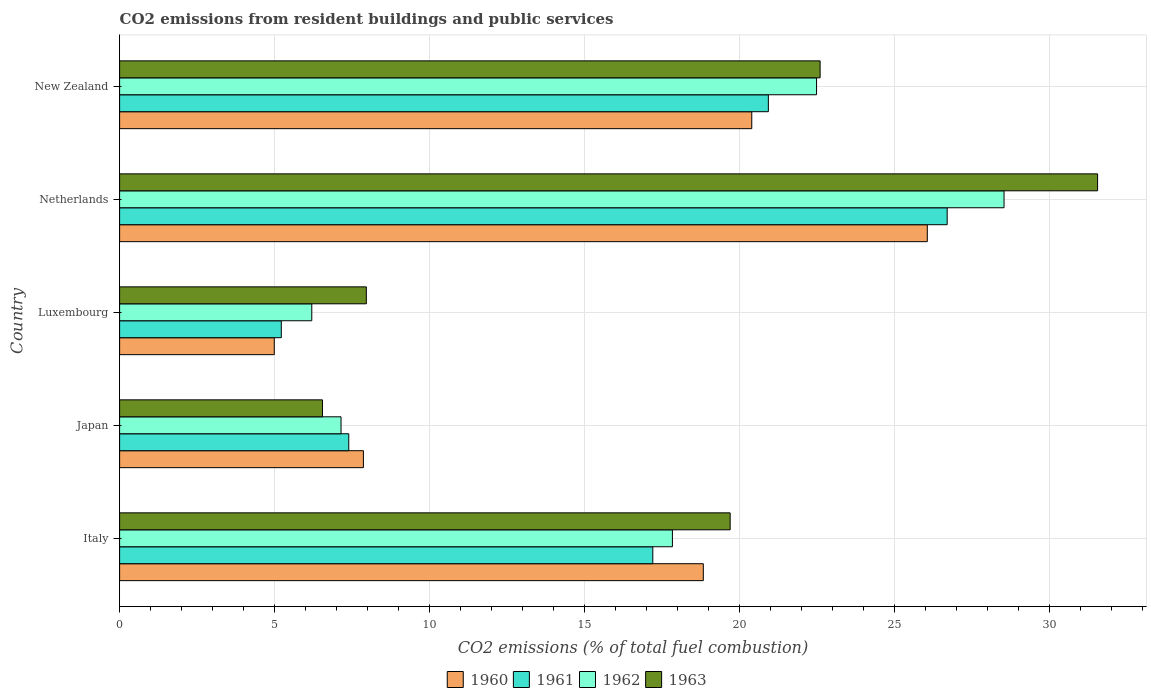How many bars are there on the 5th tick from the top?
Give a very brief answer. 4. What is the total CO2 emitted in 1961 in Italy?
Keep it short and to the point. 17.2. Across all countries, what is the maximum total CO2 emitted in 1962?
Offer a terse response. 28.52. Across all countries, what is the minimum total CO2 emitted in 1960?
Offer a very short reply. 4.99. In which country was the total CO2 emitted in 1961 maximum?
Your response must be concise. Netherlands. In which country was the total CO2 emitted in 1963 minimum?
Offer a very short reply. Japan. What is the total total CO2 emitted in 1960 in the graph?
Your response must be concise. 78.12. What is the difference between the total CO2 emitted in 1963 in Netherlands and that in New Zealand?
Provide a succinct answer. 8.95. What is the difference between the total CO2 emitted in 1963 in Japan and the total CO2 emitted in 1960 in New Zealand?
Keep it short and to the point. -13.85. What is the average total CO2 emitted in 1960 per country?
Offer a very short reply. 15.62. What is the difference between the total CO2 emitted in 1962 and total CO2 emitted in 1960 in Luxembourg?
Give a very brief answer. 1.21. What is the ratio of the total CO2 emitted in 1962 in Italy to that in Netherlands?
Provide a short and direct response. 0.63. Is the difference between the total CO2 emitted in 1962 in Italy and Luxembourg greater than the difference between the total CO2 emitted in 1960 in Italy and Luxembourg?
Give a very brief answer. No. What is the difference between the highest and the second highest total CO2 emitted in 1961?
Provide a short and direct response. 5.77. What is the difference between the highest and the lowest total CO2 emitted in 1961?
Your answer should be compact. 21.48. Is the sum of the total CO2 emitted in 1960 in Luxembourg and Netherlands greater than the maximum total CO2 emitted in 1961 across all countries?
Make the answer very short. Yes. What does the 4th bar from the bottom in Japan represents?
Your answer should be compact. 1963. How many bars are there?
Offer a terse response. 20. How many countries are there in the graph?
Provide a succinct answer. 5. What is the difference between two consecutive major ticks on the X-axis?
Make the answer very short. 5. Are the values on the major ticks of X-axis written in scientific E-notation?
Give a very brief answer. No. Does the graph contain any zero values?
Your answer should be very brief. No. Where does the legend appear in the graph?
Provide a succinct answer. Bottom center. What is the title of the graph?
Make the answer very short. CO2 emissions from resident buildings and public services. Does "1999" appear as one of the legend labels in the graph?
Make the answer very short. No. What is the label or title of the X-axis?
Offer a terse response. CO2 emissions (% of total fuel combustion). What is the label or title of the Y-axis?
Keep it short and to the point. Country. What is the CO2 emissions (% of total fuel combustion) of 1960 in Italy?
Offer a very short reply. 18.83. What is the CO2 emissions (% of total fuel combustion) in 1961 in Italy?
Provide a succinct answer. 17.2. What is the CO2 emissions (% of total fuel combustion) of 1962 in Italy?
Ensure brevity in your answer.  17.83. What is the CO2 emissions (% of total fuel combustion) of 1963 in Italy?
Ensure brevity in your answer.  19.69. What is the CO2 emissions (% of total fuel combustion) of 1960 in Japan?
Your answer should be very brief. 7.86. What is the CO2 emissions (% of total fuel combustion) in 1961 in Japan?
Ensure brevity in your answer.  7.39. What is the CO2 emissions (% of total fuel combustion) of 1962 in Japan?
Offer a terse response. 7.14. What is the CO2 emissions (% of total fuel combustion) in 1963 in Japan?
Make the answer very short. 6.54. What is the CO2 emissions (% of total fuel combustion) in 1960 in Luxembourg?
Provide a succinct answer. 4.99. What is the CO2 emissions (% of total fuel combustion) in 1961 in Luxembourg?
Offer a terse response. 5.21. What is the CO2 emissions (% of total fuel combustion) in 1962 in Luxembourg?
Give a very brief answer. 6.2. What is the CO2 emissions (% of total fuel combustion) in 1963 in Luxembourg?
Your answer should be very brief. 7.96. What is the CO2 emissions (% of total fuel combustion) of 1960 in Netherlands?
Offer a very short reply. 26.05. What is the CO2 emissions (% of total fuel combustion) of 1961 in Netherlands?
Ensure brevity in your answer.  26.69. What is the CO2 emissions (% of total fuel combustion) of 1962 in Netherlands?
Your response must be concise. 28.52. What is the CO2 emissions (% of total fuel combustion) of 1963 in Netherlands?
Offer a terse response. 31.54. What is the CO2 emissions (% of total fuel combustion) of 1960 in New Zealand?
Offer a very short reply. 20.39. What is the CO2 emissions (% of total fuel combustion) of 1961 in New Zealand?
Ensure brevity in your answer.  20.92. What is the CO2 emissions (% of total fuel combustion) of 1962 in New Zealand?
Offer a terse response. 22.48. What is the CO2 emissions (% of total fuel combustion) in 1963 in New Zealand?
Offer a terse response. 22.59. Across all countries, what is the maximum CO2 emissions (% of total fuel combustion) of 1960?
Your answer should be compact. 26.05. Across all countries, what is the maximum CO2 emissions (% of total fuel combustion) in 1961?
Keep it short and to the point. 26.69. Across all countries, what is the maximum CO2 emissions (% of total fuel combustion) of 1962?
Keep it short and to the point. 28.52. Across all countries, what is the maximum CO2 emissions (% of total fuel combustion) of 1963?
Your answer should be compact. 31.54. Across all countries, what is the minimum CO2 emissions (% of total fuel combustion) in 1960?
Your answer should be very brief. 4.99. Across all countries, what is the minimum CO2 emissions (% of total fuel combustion) of 1961?
Your answer should be very brief. 5.21. Across all countries, what is the minimum CO2 emissions (% of total fuel combustion) in 1962?
Ensure brevity in your answer.  6.2. Across all countries, what is the minimum CO2 emissions (% of total fuel combustion) of 1963?
Provide a short and direct response. 6.54. What is the total CO2 emissions (% of total fuel combustion) in 1960 in the graph?
Give a very brief answer. 78.11. What is the total CO2 emissions (% of total fuel combustion) in 1961 in the graph?
Keep it short and to the point. 77.42. What is the total CO2 emissions (% of total fuel combustion) of 1962 in the graph?
Make the answer very short. 82.17. What is the total CO2 emissions (% of total fuel combustion) in 1963 in the graph?
Keep it short and to the point. 88.33. What is the difference between the CO2 emissions (% of total fuel combustion) of 1960 in Italy and that in Japan?
Your response must be concise. 10.96. What is the difference between the CO2 emissions (% of total fuel combustion) in 1961 in Italy and that in Japan?
Your answer should be very brief. 9.81. What is the difference between the CO2 emissions (% of total fuel combustion) of 1962 in Italy and that in Japan?
Provide a succinct answer. 10.69. What is the difference between the CO2 emissions (% of total fuel combustion) of 1963 in Italy and that in Japan?
Give a very brief answer. 13.15. What is the difference between the CO2 emissions (% of total fuel combustion) of 1960 in Italy and that in Luxembourg?
Keep it short and to the point. 13.84. What is the difference between the CO2 emissions (% of total fuel combustion) in 1961 in Italy and that in Luxembourg?
Ensure brevity in your answer.  11.98. What is the difference between the CO2 emissions (% of total fuel combustion) in 1962 in Italy and that in Luxembourg?
Your response must be concise. 11.63. What is the difference between the CO2 emissions (% of total fuel combustion) in 1963 in Italy and that in Luxembourg?
Your answer should be very brief. 11.73. What is the difference between the CO2 emissions (% of total fuel combustion) of 1960 in Italy and that in Netherlands?
Ensure brevity in your answer.  -7.22. What is the difference between the CO2 emissions (% of total fuel combustion) in 1961 in Italy and that in Netherlands?
Your response must be concise. -9.49. What is the difference between the CO2 emissions (% of total fuel combustion) of 1962 in Italy and that in Netherlands?
Ensure brevity in your answer.  -10.7. What is the difference between the CO2 emissions (% of total fuel combustion) of 1963 in Italy and that in Netherlands?
Give a very brief answer. -11.85. What is the difference between the CO2 emissions (% of total fuel combustion) in 1960 in Italy and that in New Zealand?
Provide a short and direct response. -1.56. What is the difference between the CO2 emissions (% of total fuel combustion) of 1961 in Italy and that in New Zealand?
Offer a terse response. -3.73. What is the difference between the CO2 emissions (% of total fuel combustion) of 1962 in Italy and that in New Zealand?
Provide a short and direct response. -4.65. What is the difference between the CO2 emissions (% of total fuel combustion) of 1963 in Italy and that in New Zealand?
Keep it short and to the point. -2.9. What is the difference between the CO2 emissions (% of total fuel combustion) of 1960 in Japan and that in Luxembourg?
Your answer should be very brief. 2.87. What is the difference between the CO2 emissions (% of total fuel combustion) of 1961 in Japan and that in Luxembourg?
Your response must be concise. 2.18. What is the difference between the CO2 emissions (% of total fuel combustion) in 1962 in Japan and that in Luxembourg?
Offer a very short reply. 0.94. What is the difference between the CO2 emissions (% of total fuel combustion) of 1963 in Japan and that in Luxembourg?
Your response must be concise. -1.41. What is the difference between the CO2 emissions (% of total fuel combustion) in 1960 in Japan and that in Netherlands?
Keep it short and to the point. -18.19. What is the difference between the CO2 emissions (% of total fuel combustion) in 1961 in Japan and that in Netherlands?
Your response must be concise. -19.3. What is the difference between the CO2 emissions (% of total fuel combustion) of 1962 in Japan and that in Netherlands?
Provide a short and direct response. -21.38. What is the difference between the CO2 emissions (% of total fuel combustion) of 1963 in Japan and that in Netherlands?
Your answer should be very brief. -25. What is the difference between the CO2 emissions (% of total fuel combustion) of 1960 in Japan and that in New Zealand?
Offer a very short reply. -12.53. What is the difference between the CO2 emissions (% of total fuel combustion) of 1961 in Japan and that in New Zealand?
Provide a short and direct response. -13.53. What is the difference between the CO2 emissions (% of total fuel combustion) of 1962 in Japan and that in New Zealand?
Offer a terse response. -15.34. What is the difference between the CO2 emissions (% of total fuel combustion) in 1963 in Japan and that in New Zealand?
Your response must be concise. -16.05. What is the difference between the CO2 emissions (% of total fuel combustion) in 1960 in Luxembourg and that in Netherlands?
Keep it short and to the point. -21.06. What is the difference between the CO2 emissions (% of total fuel combustion) in 1961 in Luxembourg and that in Netherlands?
Keep it short and to the point. -21.48. What is the difference between the CO2 emissions (% of total fuel combustion) in 1962 in Luxembourg and that in Netherlands?
Offer a very short reply. -22.33. What is the difference between the CO2 emissions (% of total fuel combustion) of 1963 in Luxembourg and that in Netherlands?
Make the answer very short. -23.58. What is the difference between the CO2 emissions (% of total fuel combustion) of 1960 in Luxembourg and that in New Zealand?
Make the answer very short. -15.4. What is the difference between the CO2 emissions (% of total fuel combustion) of 1961 in Luxembourg and that in New Zealand?
Provide a short and direct response. -15.71. What is the difference between the CO2 emissions (% of total fuel combustion) of 1962 in Luxembourg and that in New Zealand?
Keep it short and to the point. -16.28. What is the difference between the CO2 emissions (% of total fuel combustion) of 1963 in Luxembourg and that in New Zealand?
Offer a terse response. -14.63. What is the difference between the CO2 emissions (% of total fuel combustion) of 1960 in Netherlands and that in New Zealand?
Offer a very short reply. 5.66. What is the difference between the CO2 emissions (% of total fuel combustion) of 1961 in Netherlands and that in New Zealand?
Your answer should be very brief. 5.77. What is the difference between the CO2 emissions (% of total fuel combustion) in 1962 in Netherlands and that in New Zealand?
Give a very brief answer. 6.05. What is the difference between the CO2 emissions (% of total fuel combustion) of 1963 in Netherlands and that in New Zealand?
Ensure brevity in your answer.  8.95. What is the difference between the CO2 emissions (% of total fuel combustion) in 1960 in Italy and the CO2 emissions (% of total fuel combustion) in 1961 in Japan?
Ensure brevity in your answer.  11.43. What is the difference between the CO2 emissions (% of total fuel combustion) in 1960 in Italy and the CO2 emissions (% of total fuel combustion) in 1962 in Japan?
Your answer should be compact. 11.68. What is the difference between the CO2 emissions (% of total fuel combustion) in 1960 in Italy and the CO2 emissions (% of total fuel combustion) in 1963 in Japan?
Offer a very short reply. 12.28. What is the difference between the CO2 emissions (% of total fuel combustion) of 1961 in Italy and the CO2 emissions (% of total fuel combustion) of 1962 in Japan?
Your response must be concise. 10.05. What is the difference between the CO2 emissions (% of total fuel combustion) of 1961 in Italy and the CO2 emissions (% of total fuel combustion) of 1963 in Japan?
Offer a very short reply. 10.65. What is the difference between the CO2 emissions (% of total fuel combustion) in 1962 in Italy and the CO2 emissions (% of total fuel combustion) in 1963 in Japan?
Give a very brief answer. 11.29. What is the difference between the CO2 emissions (% of total fuel combustion) of 1960 in Italy and the CO2 emissions (% of total fuel combustion) of 1961 in Luxembourg?
Your answer should be very brief. 13.61. What is the difference between the CO2 emissions (% of total fuel combustion) in 1960 in Italy and the CO2 emissions (% of total fuel combustion) in 1962 in Luxembourg?
Give a very brief answer. 12.63. What is the difference between the CO2 emissions (% of total fuel combustion) of 1960 in Italy and the CO2 emissions (% of total fuel combustion) of 1963 in Luxembourg?
Offer a very short reply. 10.87. What is the difference between the CO2 emissions (% of total fuel combustion) of 1961 in Italy and the CO2 emissions (% of total fuel combustion) of 1962 in Luxembourg?
Provide a short and direct response. 11. What is the difference between the CO2 emissions (% of total fuel combustion) of 1961 in Italy and the CO2 emissions (% of total fuel combustion) of 1963 in Luxembourg?
Your answer should be compact. 9.24. What is the difference between the CO2 emissions (% of total fuel combustion) in 1962 in Italy and the CO2 emissions (% of total fuel combustion) in 1963 in Luxembourg?
Make the answer very short. 9.87. What is the difference between the CO2 emissions (% of total fuel combustion) in 1960 in Italy and the CO2 emissions (% of total fuel combustion) in 1961 in Netherlands?
Ensure brevity in your answer.  -7.86. What is the difference between the CO2 emissions (% of total fuel combustion) in 1960 in Italy and the CO2 emissions (% of total fuel combustion) in 1962 in Netherlands?
Offer a very short reply. -9.7. What is the difference between the CO2 emissions (% of total fuel combustion) of 1960 in Italy and the CO2 emissions (% of total fuel combustion) of 1963 in Netherlands?
Your answer should be very brief. -12.72. What is the difference between the CO2 emissions (% of total fuel combustion) in 1961 in Italy and the CO2 emissions (% of total fuel combustion) in 1962 in Netherlands?
Ensure brevity in your answer.  -11.33. What is the difference between the CO2 emissions (% of total fuel combustion) of 1961 in Italy and the CO2 emissions (% of total fuel combustion) of 1963 in Netherlands?
Your answer should be compact. -14.35. What is the difference between the CO2 emissions (% of total fuel combustion) of 1962 in Italy and the CO2 emissions (% of total fuel combustion) of 1963 in Netherlands?
Offer a terse response. -13.71. What is the difference between the CO2 emissions (% of total fuel combustion) of 1960 in Italy and the CO2 emissions (% of total fuel combustion) of 1961 in New Zealand?
Make the answer very short. -2.1. What is the difference between the CO2 emissions (% of total fuel combustion) in 1960 in Italy and the CO2 emissions (% of total fuel combustion) in 1962 in New Zealand?
Your response must be concise. -3.65. What is the difference between the CO2 emissions (% of total fuel combustion) in 1960 in Italy and the CO2 emissions (% of total fuel combustion) in 1963 in New Zealand?
Offer a very short reply. -3.77. What is the difference between the CO2 emissions (% of total fuel combustion) of 1961 in Italy and the CO2 emissions (% of total fuel combustion) of 1962 in New Zealand?
Make the answer very short. -5.28. What is the difference between the CO2 emissions (% of total fuel combustion) in 1961 in Italy and the CO2 emissions (% of total fuel combustion) in 1963 in New Zealand?
Give a very brief answer. -5.4. What is the difference between the CO2 emissions (% of total fuel combustion) in 1962 in Italy and the CO2 emissions (% of total fuel combustion) in 1963 in New Zealand?
Your answer should be compact. -4.76. What is the difference between the CO2 emissions (% of total fuel combustion) in 1960 in Japan and the CO2 emissions (% of total fuel combustion) in 1961 in Luxembourg?
Provide a short and direct response. 2.65. What is the difference between the CO2 emissions (% of total fuel combustion) in 1960 in Japan and the CO2 emissions (% of total fuel combustion) in 1962 in Luxembourg?
Give a very brief answer. 1.66. What is the difference between the CO2 emissions (% of total fuel combustion) in 1960 in Japan and the CO2 emissions (% of total fuel combustion) in 1963 in Luxembourg?
Keep it short and to the point. -0.09. What is the difference between the CO2 emissions (% of total fuel combustion) in 1961 in Japan and the CO2 emissions (% of total fuel combustion) in 1962 in Luxembourg?
Offer a terse response. 1.19. What is the difference between the CO2 emissions (% of total fuel combustion) in 1961 in Japan and the CO2 emissions (% of total fuel combustion) in 1963 in Luxembourg?
Provide a short and direct response. -0.57. What is the difference between the CO2 emissions (% of total fuel combustion) of 1962 in Japan and the CO2 emissions (% of total fuel combustion) of 1963 in Luxembourg?
Your answer should be very brief. -0.82. What is the difference between the CO2 emissions (% of total fuel combustion) of 1960 in Japan and the CO2 emissions (% of total fuel combustion) of 1961 in Netherlands?
Your answer should be compact. -18.83. What is the difference between the CO2 emissions (% of total fuel combustion) of 1960 in Japan and the CO2 emissions (% of total fuel combustion) of 1962 in Netherlands?
Offer a very short reply. -20.66. What is the difference between the CO2 emissions (% of total fuel combustion) in 1960 in Japan and the CO2 emissions (% of total fuel combustion) in 1963 in Netherlands?
Ensure brevity in your answer.  -23.68. What is the difference between the CO2 emissions (% of total fuel combustion) of 1961 in Japan and the CO2 emissions (% of total fuel combustion) of 1962 in Netherlands?
Provide a succinct answer. -21.13. What is the difference between the CO2 emissions (% of total fuel combustion) of 1961 in Japan and the CO2 emissions (% of total fuel combustion) of 1963 in Netherlands?
Give a very brief answer. -24.15. What is the difference between the CO2 emissions (% of total fuel combustion) in 1962 in Japan and the CO2 emissions (% of total fuel combustion) in 1963 in Netherlands?
Make the answer very short. -24.4. What is the difference between the CO2 emissions (% of total fuel combustion) in 1960 in Japan and the CO2 emissions (% of total fuel combustion) in 1961 in New Zealand?
Give a very brief answer. -13.06. What is the difference between the CO2 emissions (% of total fuel combustion) of 1960 in Japan and the CO2 emissions (% of total fuel combustion) of 1962 in New Zealand?
Make the answer very short. -14.61. What is the difference between the CO2 emissions (% of total fuel combustion) in 1960 in Japan and the CO2 emissions (% of total fuel combustion) in 1963 in New Zealand?
Provide a short and direct response. -14.73. What is the difference between the CO2 emissions (% of total fuel combustion) of 1961 in Japan and the CO2 emissions (% of total fuel combustion) of 1962 in New Zealand?
Your answer should be very brief. -15.09. What is the difference between the CO2 emissions (% of total fuel combustion) of 1961 in Japan and the CO2 emissions (% of total fuel combustion) of 1963 in New Zealand?
Ensure brevity in your answer.  -15.2. What is the difference between the CO2 emissions (% of total fuel combustion) of 1962 in Japan and the CO2 emissions (% of total fuel combustion) of 1963 in New Zealand?
Your answer should be compact. -15.45. What is the difference between the CO2 emissions (% of total fuel combustion) in 1960 in Luxembourg and the CO2 emissions (% of total fuel combustion) in 1961 in Netherlands?
Provide a succinct answer. -21.7. What is the difference between the CO2 emissions (% of total fuel combustion) in 1960 in Luxembourg and the CO2 emissions (% of total fuel combustion) in 1962 in Netherlands?
Keep it short and to the point. -23.54. What is the difference between the CO2 emissions (% of total fuel combustion) in 1960 in Luxembourg and the CO2 emissions (% of total fuel combustion) in 1963 in Netherlands?
Offer a very short reply. -26.55. What is the difference between the CO2 emissions (% of total fuel combustion) of 1961 in Luxembourg and the CO2 emissions (% of total fuel combustion) of 1962 in Netherlands?
Offer a terse response. -23.31. What is the difference between the CO2 emissions (% of total fuel combustion) of 1961 in Luxembourg and the CO2 emissions (% of total fuel combustion) of 1963 in Netherlands?
Your response must be concise. -26.33. What is the difference between the CO2 emissions (% of total fuel combustion) of 1962 in Luxembourg and the CO2 emissions (% of total fuel combustion) of 1963 in Netherlands?
Provide a succinct answer. -25.34. What is the difference between the CO2 emissions (% of total fuel combustion) in 1960 in Luxembourg and the CO2 emissions (% of total fuel combustion) in 1961 in New Zealand?
Your answer should be very brief. -15.94. What is the difference between the CO2 emissions (% of total fuel combustion) in 1960 in Luxembourg and the CO2 emissions (% of total fuel combustion) in 1962 in New Zealand?
Provide a short and direct response. -17.49. What is the difference between the CO2 emissions (% of total fuel combustion) of 1960 in Luxembourg and the CO2 emissions (% of total fuel combustion) of 1963 in New Zealand?
Keep it short and to the point. -17.6. What is the difference between the CO2 emissions (% of total fuel combustion) of 1961 in Luxembourg and the CO2 emissions (% of total fuel combustion) of 1962 in New Zealand?
Your answer should be very brief. -17.26. What is the difference between the CO2 emissions (% of total fuel combustion) in 1961 in Luxembourg and the CO2 emissions (% of total fuel combustion) in 1963 in New Zealand?
Make the answer very short. -17.38. What is the difference between the CO2 emissions (% of total fuel combustion) in 1962 in Luxembourg and the CO2 emissions (% of total fuel combustion) in 1963 in New Zealand?
Make the answer very short. -16.39. What is the difference between the CO2 emissions (% of total fuel combustion) in 1960 in Netherlands and the CO2 emissions (% of total fuel combustion) in 1961 in New Zealand?
Offer a very short reply. 5.13. What is the difference between the CO2 emissions (% of total fuel combustion) of 1960 in Netherlands and the CO2 emissions (% of total fuel combustion) of 1962 in New Zealand?
Ensure brevity in your answer.  3.57. What is the difference between the CO2 emissions (% of total fuel combustion) in 1960 in Netherlands and the CO2 emissions (% of total fuel combustion) in 1963 in New Zealand?
Your response must be concise. 3.46. What is the difference between the CO2 emissions (% of total fuel combustion) of 1961 in Netherlands and the CO2 emissions (% of total fuel combustion) of 1962 in New Zealand?
Give a very brief answer. 4.21. What is the difference between the CO2 emissions (% of total fuel combustion) in 1961 in Netherlands and the CO2 emissions (% of total fuel combustion) in 1963 in New Zealand?
Keep it short and to the point. 4.1. What is the difference between the CO2 emissions (% of total fuel combustion) in 1962 in Netherlands and the CO2 emissions (% of total fuel combustion) in 1963 in New Zealand?
Ensure brevity in your answer.  5.93. What is the average CO2 emissions (% of total fuel combustion) in 1960 per country?
Offer a very short reply. 15.62. What is the average CO2 emissions (% of total fuel combustion) in 1961 per country?
Provide a short and direct response. 15.48. What is the average CO2 emissions (% of total fuel combustion) of 1962 per country?
Offer a terse response. 16.43. What is the average CO2 emissions (% of total fuel combustion) in 1963 per country?
Your answer should be very brief. 17.67. What is the difference between the CO2 emissions (% of total fuel combustion) in 1960 and CO2 emissions (% of total fuel combustion) in 1961 in Italy?
Your answer should be compact. 1.63. What is the difference between the CO2 emissions (% of total fuel combustion) of 1960 and CO2 emissions (% of total fuel combustion) of 1962 in Italy?
Offer a terse response. 1. What is the difference between the CO2 emissions (% of total fuel combustion) in 1960 and CO2 emissions (% of total fuel combustion) in 1963 in Italy?
Make the answer very short. -0.87. What is the difference between the CO2 emissions (% of total fuel combustion) of 1961 and CO2 emissions (% of total fuel combustion) of 1962 in Italy?
Your answer should be very brief. -0.63. What is the difference between the CO2 emissions (% of total fuel combustion) in 1961 and CO2 emissions (% of total fuel combustion) in 1963 in Italy?
Make the answer very short. -2.49. What is the difference between the CO2 emissions (% of total fuel combustion) in 1962 and CO2 emissions (% of total fuel combustion) in 1963 in Italy?
Offer a very short reply. -1.86. What is the difference between the CO2 emissions (% of total fuel combustion) of 1960 and CO2 emissions (% of total fuel combustion) of 1961 in Japan?
Ensure brevity in your answer.  0.47. What is the difference between the CO2 emissions (% of total fuel combustion) in 1960 and CO2 emissions (% of total fuel combustion) in 1962 in Japan?
Provide a succinct answer. 0.72. What is the difference between the CO2 emissions (% of total fuel combustion) of 1960 and CO2 emissions (% of total fuel combustion) of 1963 in Japan?
Ensure brevity in your answer.  1.32. What is the difference between the CO2 emissions (% of total fuel combustion) of 1961 and CO2 emissions (% of total fuel combustion) of 1962 in Japan?
Provide a succinct answer. 0.25. What is the difference between the CO2 emissions (% of total fuel combustion) in 1961 and CO2 emissions (% of total fuel combustion) in 1963 in Japan?
Your answer should be compact. 0.85. What is the difference between the CO2 emissions (% of total fuel combustion) in 1962 and CO2 emissions (% of total fuel combustion) in 1963 in Japan?
Offer a terse response. 0.6. What is the difference between the CO2 emissions (% of total fuel combustion) of 1960 and CO2 emissions (% of total fuel combustion) of 1961 in Luxembourg?
Ensure brevity in your answer.  -0.23. What is the difference between the CO2 emissions (% of total fuel combustion) of 1960 and CO2 emissions (% of total fuel combustion) of 1962 in Luxembourg?
Provide a succinct answer. -1.21. What is the difference between the CO2 emissions (% of total fuel combustion) in 1960 and CO2 emissions (% of total fuel combustion) in 1963 in Luxembourg?
Your response must be concise. -2.97. What is the difference between the CO2 emissions (% of total fuel combustion) in 1961 and CO2 emissions (% of total fuel combustion) in 1962 in Luxembourg?
Keep it short and to the point. -0.98. What is the difference between the CO2 emissions (% of total fuel combustion) of 1961 and CO2 emissions (% of total fuel combustion) of 1963 in Luxembourg?
Your answer should be very brief. -2.74. What is the difference between the CO2 emissions (% of total fuel combustion) in 1962 and CO2 emissions (% of total fuel combustion) in 1963 in Luxembourg?
Your answer should be compact. -1.76. What is the difference between the CO2 emissions (% of total fuel combustion) of 1960 and CO2 emissions (% of total fuel combustion) of 1961 in Netherlands?
Your response must be concise. -0.64. What is the difference between the CO2 emissions (% of total fuel combustion) in 1960 and CO2 emissions (% of total fuel combustion) in 1962 in Netherlands?
Your answer should be very brief. -2.47. What is the difference between the CO2 emissions (% of total fuel combustion) of 1960 and CO2 emissions (% of total fuel combustion) of 1963 in Netherlands?
Your answer should be compact. -5.49. What is the difference between the CO2 emissions (% of total fuel combustion) in 1961 and CO2 emissions (% of total fuel combustion) in 1962 in Netherlands?
Offer a very short reply. -1.83. What is the difference between the CO2 emissions (% of total fuel combustion) of 1961 and CO2 emissions (% of total fuel combustion) of 1963 in Netherlands?
Offer a very short reply. -4.85. What is the difference between the CO2 emissions (% of total fuel combustion) of 1962 and CO2 emissions (% of total fuel combustion) of 1963 in Netherlands?
Provide a short and direct response. -3.02. What is the difference between the CO2 emissions (% of total fuel combustion) of 1960 and CO2 emissions (% of total fuel combustion) of 1961 in New Zealand?
Offer a very short reply. -0.54. What is the difference between the CO2 emissions (% of total fuel combustion) of 1960 and CO2 emissions (% of total fuel combustion) of 1962 in New Zealand?
Offer a very short reply. -2.09. What is the difference between the CO2 emissions (% of total fuel combustion) in 1960 and CO2 emissions (% of total fuel combustion) in 1963 in New Zealand?
Offer a very short reply. -2.2. What is the difference between the CO2 emissions (% of total fuel combustion) of 1961 and CO2 emissions (% of total fuel combustion) of 1962 in New Zealand?
Your answer should be compact. -1.55. What is the difference between the CO2 emissions (% of total fuel combustion) of 1961 and CO2 emissions (% of total fuel combustion) of 1963 in New Zealand?
Offer a terse response. -1.67. What is the difference between the CO2 emissions (% of total fuel combustion) in 1962 and CO2 emissions (% of total fuel combustion) in 1963 in New Zealand?
Provide a succinct answer. -0.12. What is the ratio of the CO2 emissions (% of total fuel combustion) of 1960 in Italy to that in Japan?
Provide a short and direct response. 2.39. What is the ratio of the CO2 emissions (% of total fuel combustion) of 1961 in Italy to that in Japan?
Ensure brevity in your answer.  2.33. What is the ratio of the CO2 emissions (% of total fuel combustion) in 1962 in Italy to that in Japan?
Keep it short and to the point. 2.5. What is the ratio of the CO2 emissions (% of total fuel combustion) of 1963 in Italy to that in Japan?
Keep it short and to the point. 3.01. What is the ratio of the CO2 emissions (% of total fuel combustion) in 1960 in Italy to that in Luxembourg?
Give a very brief answer. 3.77. What is the ratio of the CO2 emissions (% of total fuel combustion) of 1961 in Italy to that in Luxembourg?
Provide a short and direct response. 3.3. What is the ratio of the CO2 emissions (% of total fuel combustion) of 1962 in Italy to that in Luxembourg?
Provide a short and direct response. 2.88. What is the ratio of the CO2 emissions (% of total fuel combustion) in 1963 in Italy to that in Luxembourg?
Make the answer very short. 2.47. What is the ratio of the CO2 emissions (% of total fuel combustion) of 1960 in Italy to that in Netherlands?
Your answer should be compact. 0.72. What is the ratio of the CO2 emissions (% of total fuel combustion) in 1961 in Italy to that in Netherlands?
Make the answer very short. 0.64. What is the ratio of the CO2 emissions (% of total fuel combustion) in 1962 in Italy to that in Netherlands?
Give a very brief answer. 0.62. What is the ratio of the CO2 emissions (% of total fuel combustion) of 1963 in Italy to that in Netherlands?
Give a very brief answer. 0.62. What is the ratio of the CO2 emissions (% of total fuel combustion) of 1960 in Italy to that in New Zealand?
Your answer should be compact. 0.92. What is the ratio of the CO2 emissions (% of total fuel combustion) of 1961 in Italy to that in New Zealand?
Offer a terse response. 0.82. What is the ratio of the CO2 emissions (% of total fuel combustion) of 1962 in Italy to that in New Zealand?
Keep it short and to the point. 0.79. What is the ratio of the CO2 emissions (% of total fuel combustion) of 1963 in Italy to that in New Zealand?
Your response must be concise. 0.87. What is the ratio of the CO2 emissions (% of total fuel combustion) in 1960 in Japan to that in Luxembourg?
Your response must be concise. 1.58. What is the ratio of the CO2 emissions (% of total fuel combustion) in 1961 in Japan to that in Luxembourg?
Provide a short and direct response. 1.42. What is the ratio of the CO2 emissions (% of total fuel combustion) of 1962 in Japan to that in Luxembourg?
Keep it short and to the point. 1.15. What is the ratio of the CO2 emissions (% of total fuel combustion) of 1963 in Japan to that in Luxembourg?
Ensure brevity in your answer.  0.82. What is the ratio of the CO2 emissions (% of total fuel combustion) of 1960 in Japan to that in Netherlands?
Ensure brevity in your answer.  0.3. What is the ratio of the CO2 emissions (% of total fuel combustion) of 1961 in Japan to that in Netherlands?
Provide a succinct answer. 0.28. What is the ratio of the CO2 emissions (% of total fuel combustion) in 1962 in Japan to that in Netherlands?
Offer a very short reply. 0.25. What is the ratio of the CO2 emissions (% of total fuel combustion) in 1963 in Japan to that in Netherlands?
Give a very brief answer. 0.21. What is the ratio of the CO2 emissions (% of total fuel combustion) in 1960 in Japan to that in New Zealand?
Give a very brief answer. 0.39. What is the ratio of the CO2 emissions (% of total fuel combustion) in 1961 in Japan to that in New Zealand?
Provide a succinct answer. 0.35. What is the ratio of the CO2 emissions (% of total fuel combustion) in 1962 in Japan to that in New Zealand?
Your answer should be compact. 0.32. What is the ratio of the CO2 emissions (% of total fuel combustion) in 1963 in Japan to that in New Zealand?
Keep it short and to the point. 0.29. What is the ratio of the CO2 emissions (% of total fuel combustion) in 1960 in Luxembourg to that in Netherlands?
Give a very brief answer. 0.19. What is the ratio of the CO2 emissions (% of total fuel combustion) of 1961 in Luxembourg to that in Netherlands?
Your response must be concise. 0.2. What is the ratio of the CO2 emissions (% of total fuel combustion) of 1962 in Luxembourg to that in Netherlands?
Keep it short and to the point. 0.22. What is the ratio of the CO2 emissions (% of total fuel combustion) of 1963 in Luxembourg to that in Netherlands?
Make the answer very short. 0.25. What is the ratio of the CO2 emissions (% of total fuel combustion) in 1960 in Luxembourg to that in New Zealand?
Offer a very short reply. 0.24. What is the ratio of the CO2 emissions (% of total fuel combustion) in 1961 in Luxembourg to that in New Zealand?
Offer a very short reply. 0.25. What is the ratio of the CO2 emissions (% of total fuel combustion) of 1962 in Luxembourg to that in New Zealand?
Keep it short and to the point. 0.28. What is the ratio of the CO2 emissions (% of total fuel combustion) in 1963 in Luxembourg to that in New Zealand?
Make the answer very short. 0.35. What is the ratio of the CO2 emissions (% of total fuel combustion) in 1960 in Netherlands to that in New Zealand?
Make the answer very short. 1.28. What is the ratio of the CO2 emissions (% of total fuel combustion) in 1961 in Netherlands to that in New Zealand?
Provide a succinct answer. 1.28. What is the ratio of the CO2 emissions (% of total fuel combustion) in 1962 in Netherlands to that in New Zealand?
Ensure brevity in your answer.  1.27. What is the ratio of the CO2 emissions (% of total fuel combustion) in 1963 in Netherlands to that in New Zealand?
Offer a very short reply. 1.4. What is the difference between the highest and the second highest CO2 emissions (% of total fuel combustion) in 1960?
Your answer should be compact. 5.66. What is the difference between the highest and the second highest CO2 emissions (% of total fuel combustion) in 1961?
Your answer should be compact. 5.77. What is the difference between the highest and the second highest CO2 emissions (% of total fuel combustion) in 1962?
Offer a very short reply. 6.05. What is the difference between the highest and the second highest CO2 emissions (% of total fuel combustion) of 1963?
Make the answer very short. 8.95. What is the difference between the highest and the lowest CO2 emissions (% of total fuel combustion) of 1960?
Make the answer very short. 21.06. What is the difference between the highest and the lowest CO2 emissions (% of total fuel combustion) in 1961?
Make the answer very short. 21.48. What is the difference between the highest and the lowest CO2 emissions (% of total fuel combustion) in 1962?
Provide a short and direct response. 22.33. What is the difference between the highest and the lowest CO2 emissions (% of total fuel combustion) in 1963?
Provide a succinct answer. 25. 